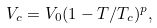<formula> <loc_0><loc_0><loc_500><loc_500>V _ { c } = V _ { 0 } ( 1 - T / T _ { c } ) ^ { p } ,</formula> 